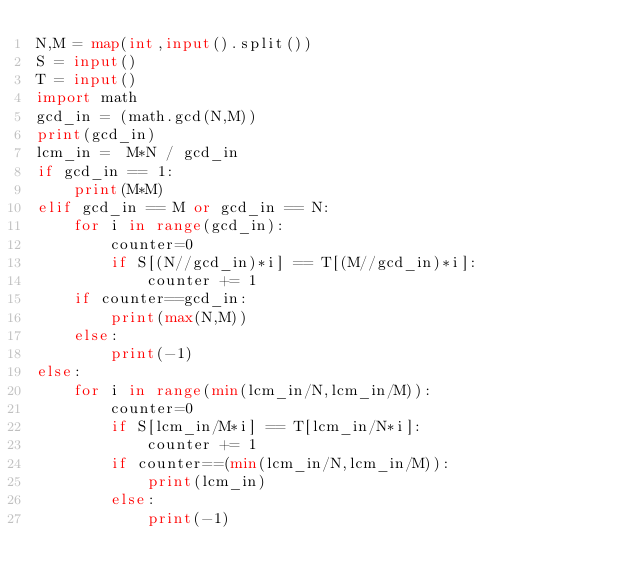Convert code to text. <code><loc_0><loc_0><loc_500><loc_500><_Python_>N,M = map(int,input().split())
S = input()
T = input()
import math
gcd_in = (math.gcd(N,M))
print(gcd_in)
lcm_in =  M*N / gcd_in
if gcd_in == 1:
    print(M*M)
elif gcd_in == M or gcd_in == N:
    for i in range(gcd_in):
        counter=0
        if S[(N//gcd_in)*i] == T[(M//gcd_in)*i]:
            counter += 1
    if counter==gcd_in:
        print(max(N,M))
    else:
        print(-1)
else:
    for i in range(min(lcm_in/N,lcm_in/M)):
        counter=0
        if S[lcm_in/M*i] == T[lcm_in/N*i]:
            counter += 1
        if counter==(min(lcm_in/N,lcm_in/M)):
            print(lcm_in)
        else:
            print(-1)</code> 